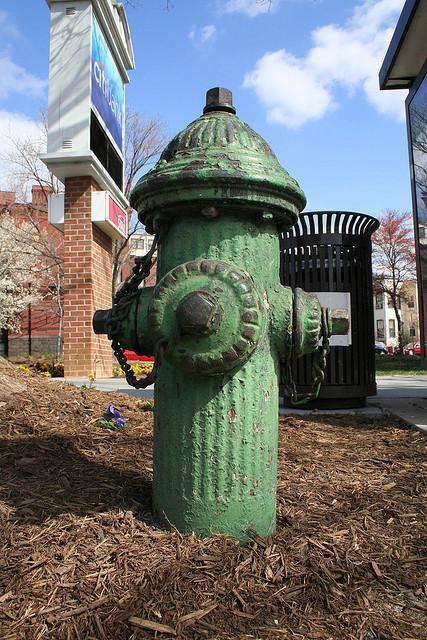How many trash bins are there?
Give a very brief answer. 1. 